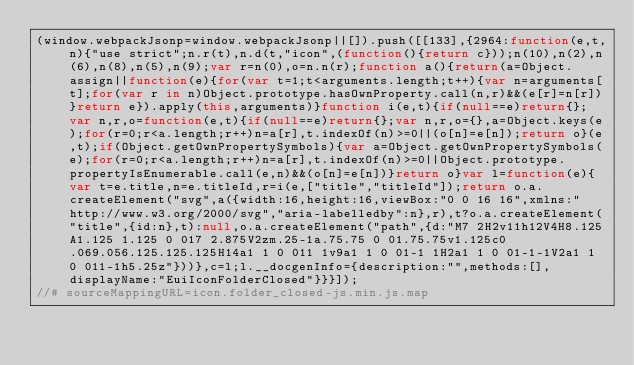Convert code to text. <code><loc_0><loc_0><loc_500><loc_500><_JavaScript_>(window.webpackJsonp=window.webpackJsonp||[]).push([[133],{2964:function(e,t,n){"use strict";n.r(t),n.d(t,"icon",(function(){return c}));n(10),n(2),n(6),n(8),n(5),n(9);var r=n(0),o=n.n(r);function a(){return(a=Object.assign||function(e){for(var t=1;t<arguments.length;t++){var n=arguments[t];for(var r in n)Object.prototype.hasOwnProperty.call(n,r)&&(e[r]=n[r])}return e}).apply(this,arguments)}function i(e,t){if(null==e)return{};var n,r,o=function(e,t){if(null==e)return{};var n,r,o={},a=Object.keys(e);for(r=0;r<a.length;r++)n=a[r],t.indexOf(n)>=0||(o[n]=e[n]);return o}(e,t);if(Object.getOwnPropertySymbols){var a=Object.getOwnPropertySymbols(e);for(r=0;r<a.length;r++)n=a[r],t.indexOf(n)>=0||Object.prototype.propertyIsEnumerable.call(e,n)&&(o[n]=e[n])}return o}var l=function(e){var t=e.title,n=e.titleId,r=i(e,["title","titleId"]);return o.a.createElement("svg",a({width:16,height:16,viewBox:"0 0 16 16",xmlns:"http://www.w3.org/2000/svg","aria-labelledby":n},r),t?o.a.createElement("title",{id:n},t):null,o.a.createElement("path",{d:"M7 2H2v11h12V4H8.125A1.125 1.125 0 017 2.875V2zm.25-1a.75.75 0 01.75.75v1.125c0 .069.056.125.125.125H14a1 1 0 011 1v9a1 1 0 01-1 1H2a1 1 0 01-1-1V2a1 1 0 011-1h5.25z"}))},c=l;l.__docgenInfo={description:"",methods:[],displayName:"EuiIconFolderClosed"}}}]);
//# sourceMappingURL=icon.folder_closed-js.min.js.map</code> 